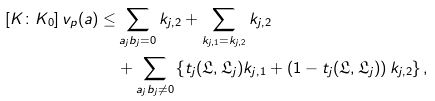Convert formula to latex. <formula><loc_0><loc_0><loc_500><loc_500>[ K \colon K _ { 0 } ] \, v _ { p } ( a ) \leq & \sum _ { a _ { j } b _ { j } = 0 } k _ { j , 2 } + \sum _ { k _ { j , 1 } = k _ { j , 2 } } k _ { j , 2 } \\ & + \sum _ { a _ { j } b _ { j } \neq 0 } \left \{ t _ { j } ( \mathfrak { L } , \mathfrak { L } _ { j } ) k _ { j , 1 } + \left ( 1 - t _ { j } ( \mathfrak { L } , \mathfrak { L } _ { j } ) \right ) k _ { j , 2 } \right \} ,</formula> 